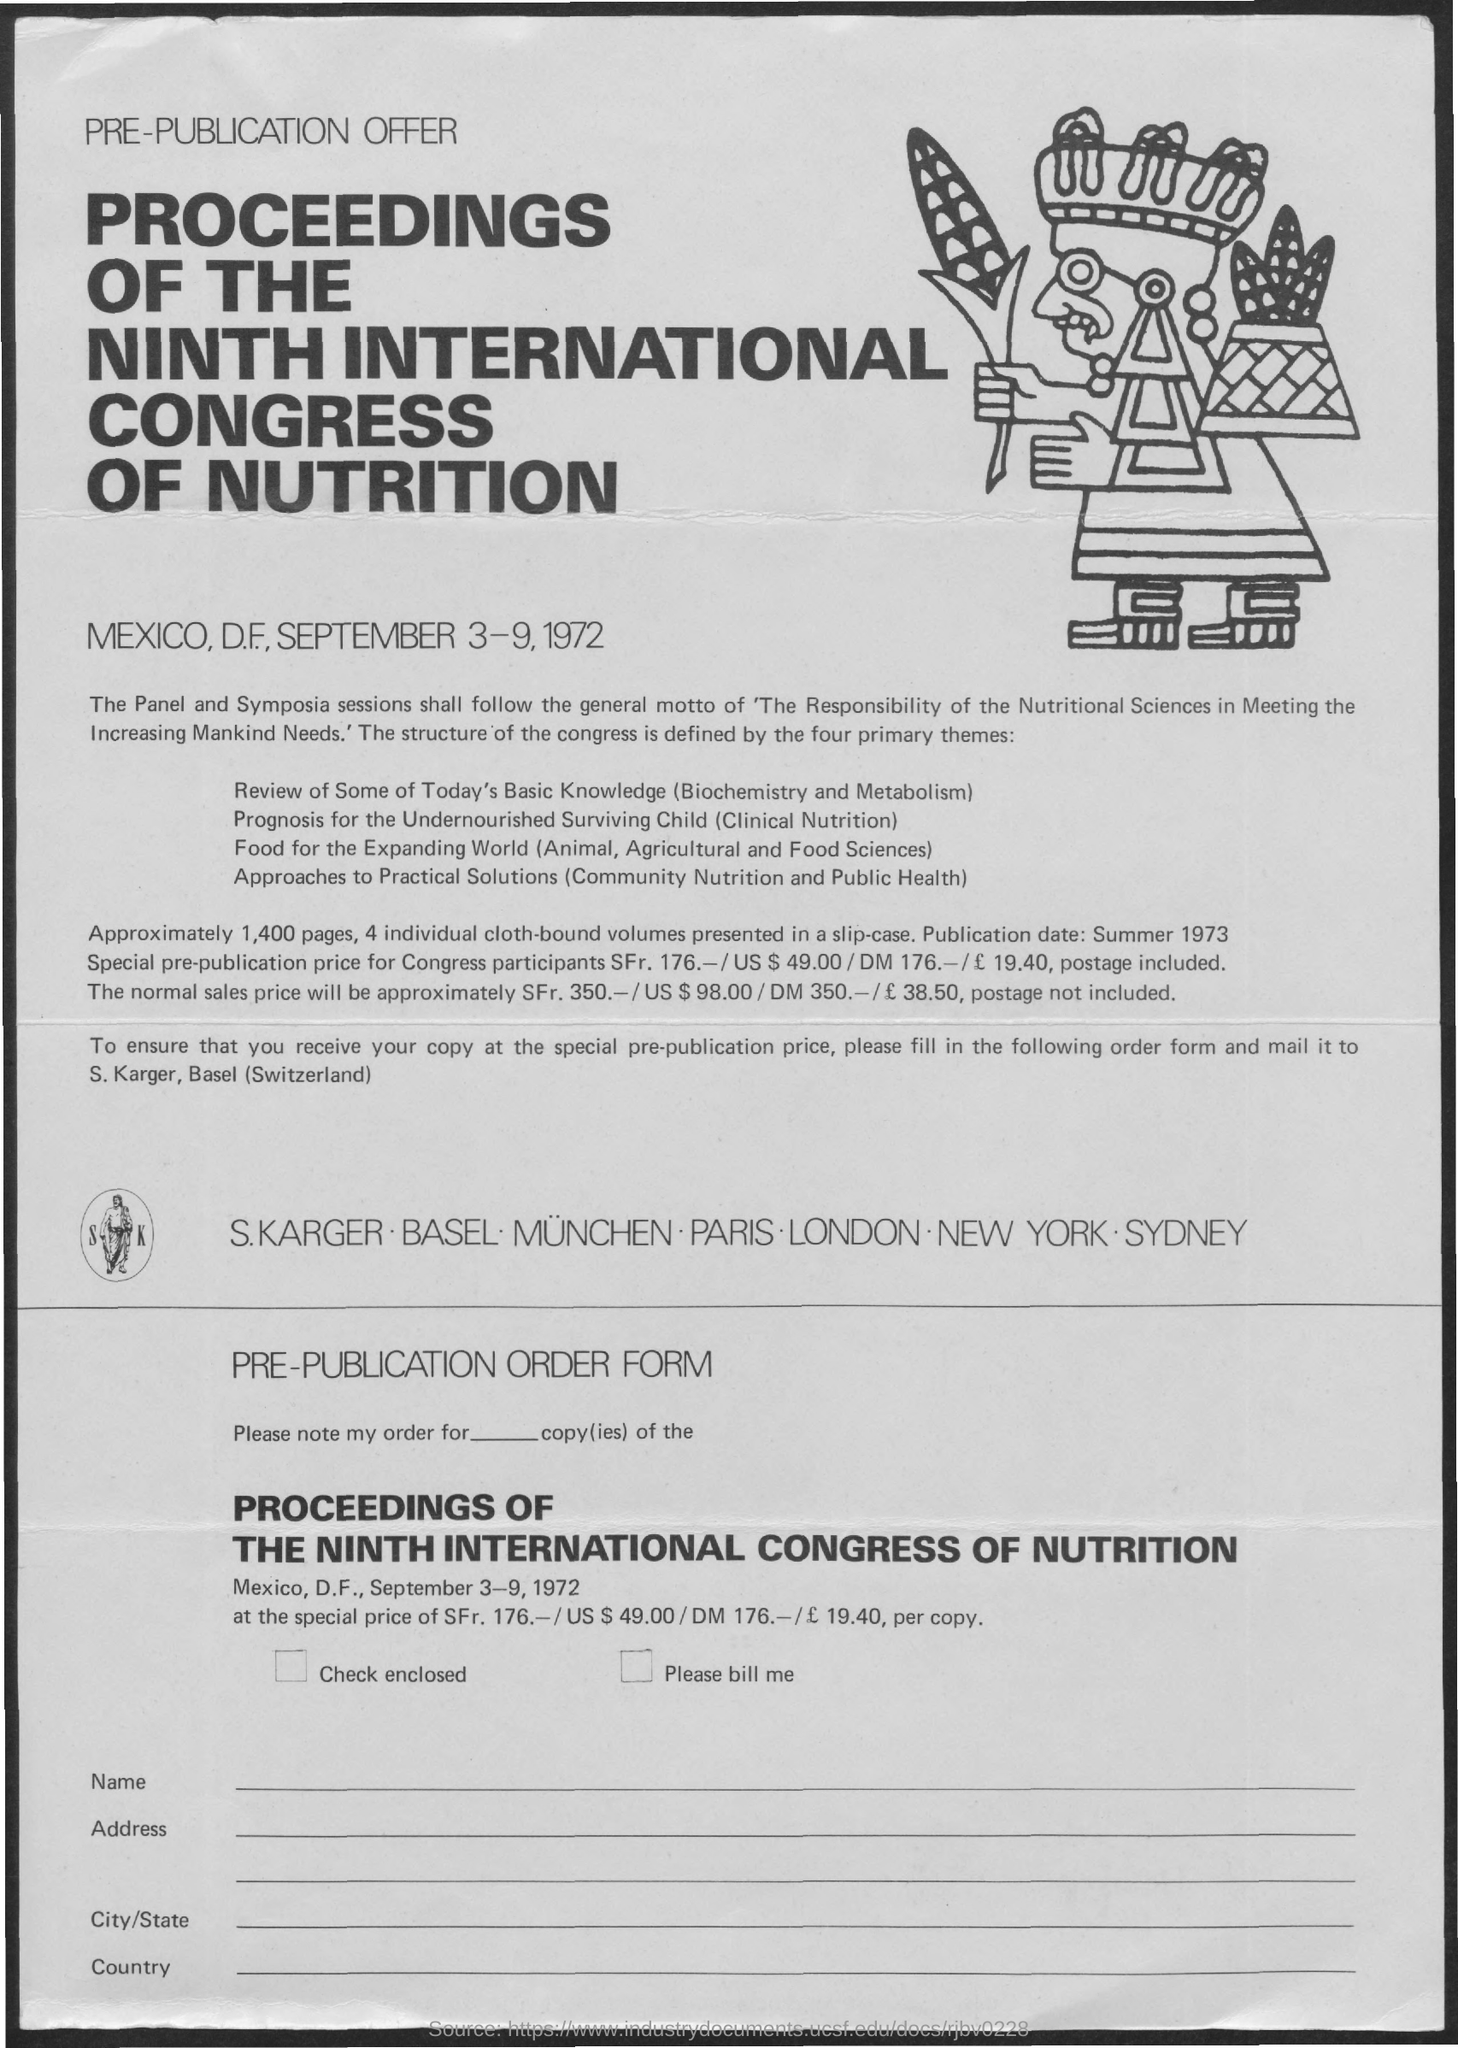Point out several critical features in this image. Four cloth-bound volumes are available. The proceedings consist of approximately 1,400 pages. The Proceedings of the Ninth International Congress of Nutrition took place from September 3-9, 1972. The Ninth International Congress of Nutrition was held in Mexico. The publication date is summer 1973. 